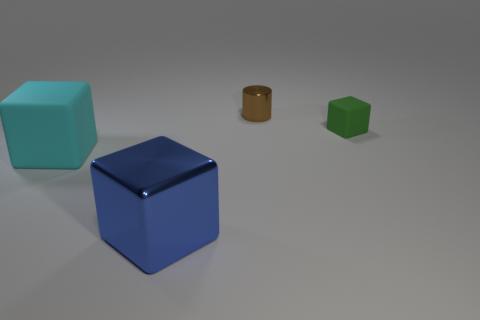Subtract all rubber cubes. How many cubes are left? 1 Add 4 small rubber cubes. How many objects exist? 8 Subtract all blocks. How many objects are left? 1 Subtract 2 cubes. How many cubes are left? 1 Subtract all blue blocks. How many blocks are left? 2 Subtract all red cylinders. Subtract all green spheres. How many cylinders are left? 1 Subtract all brown cylinders. How many blue cubes are left? 1 Subtract all green blocks. Subtract all green blocks. How many objects are left? 2 Add 4 cyan rubber things. How many cyan rubber things are left? 5 Add 2 green blocks. How many green blocks exist? 3 